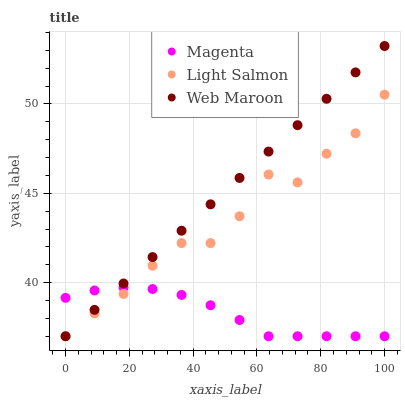Does Magenta have the minimum area under the curve?
Answer yes or no. Yes. Does Web Maroon have the maximum area under the curve?
Answer yes or no. Yes. Does Light Salmon have the minimum area under the curve?
Answer yes or no. No. Does Light Salmon have the maximum area under the curve?
Answer yes or no. No. Is Web Maroon the smoothest?
Answer yes or no. Yes. Is Light Salmon the roughest?
Answer yes or no. Yes. Is Light Salmon the smoothest?
Answer yes or no. No. Is Web Maroon the roughest?
Answer yes or no. No. Does Magenta have the lowest value?
Answer yes or no. Yes. Does Web Maroon have the highest value?
Answer yes or no. Yes. Does Light Salmon have the highest value?
Answer yes or no. No. Does Web Maroon intersect Light Salmon?
Answer yes or no. Yes. Is Web Maroon less than Light Salmon?
Answer yes or no. No. Is Web Maroon greater than Light Salmon?
Answer yes or no. No. 